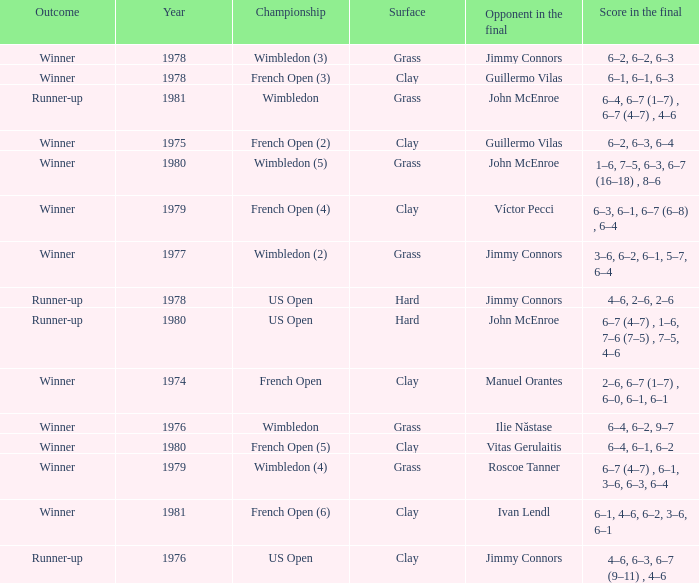What is every score in the final for opponent in final John Mcenroe at US Open? 6–7 (4–7) , 1–6, 7–6 (7–5) , 7–5, 4–6. 